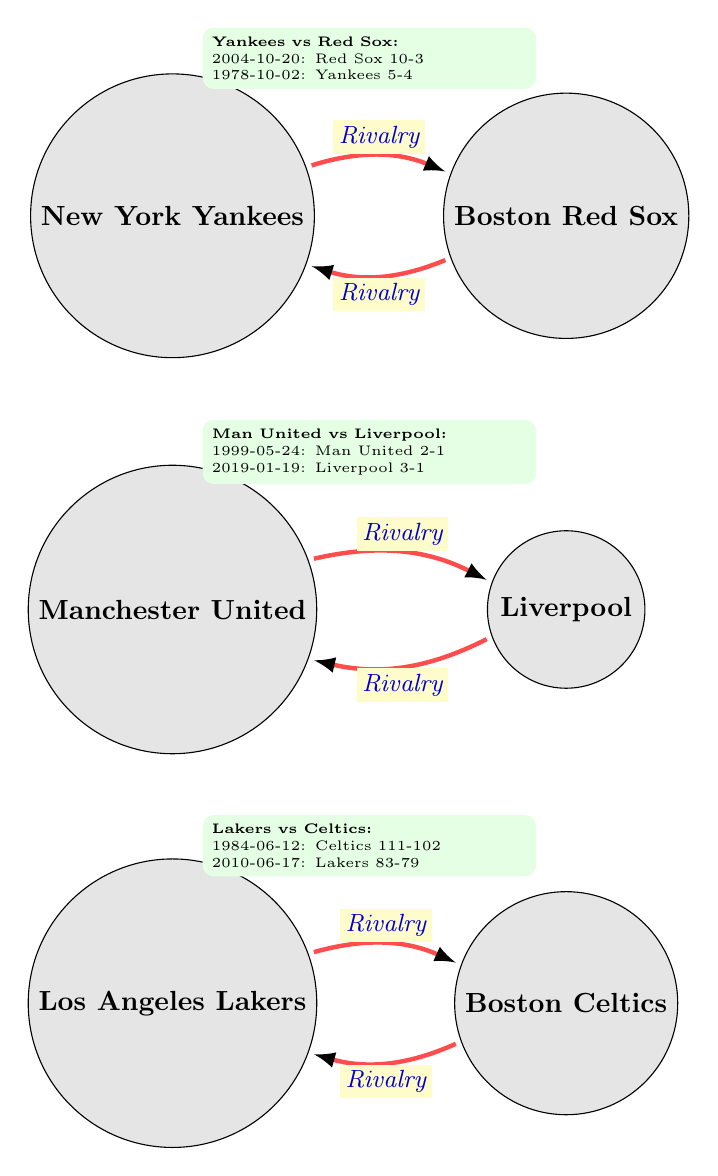What two teams are connected by the rivalry link in the top section of the diagram? The top section features a rivalry link between the New York Yankees and the Boston Red Sox. You can see that these two teams have a labeled edge connecting them, indicating their rivalry.
Answer: New York Yankees, Boston Red Sox How many nodes are in the diagram? The diagram has a total of six nodes, each representing a sports team. Counting the nodes labeled as teams, we find: Yankees, Red Sox, Manchester United, Liverpool, Lakers, and Celtics, making a total of six.
Answer: 6 What was the outcome of the historic match on 2004-10-20 between the Yankees and the Red Sox? The historical match on 2004-10-20 indicates that the Boston Red Sox won against the New York Yankees. This outcome is highlighted in the rivalry information between these two teams.
Answer: Red Sox Win Which team lost on June 12, 1984, in the historic match between the Lakers and Celtics? In the historical match on June 12, 1984, the Los Angeles Lakers lost to the Boston Celtics. The match details show the Celtics winning by a score of 111-102.
Answer: Lakers What is the significance of the match where Manchester United won against Liverpool on May 24, 1999? The significance of the match where Manchester United won against Liverpool on May 24, 1999, is noted as it was part of the FA Cup and pivotal in United's Treble-winning season. This context is provided in the historical match details.
Answer: FA Cup, United's Treble-winning season Which rivalry link is positioned at the bottom of the diagram? The rivalry link positioned at the bottom of the diagram connects the Los Angeles Lakers and the Boston Celtics. This edge is located lower than the other rivalries listed in the chart.
Answer: Lakers, Celtics What score did the Celtics win by in the historic match against the Lakers on June 17, 2010? The historical match on June 17, 2010, shows that the Boston Celtics won against the Los Angeles Lakers with a score of 83-79. This detail is clearly found in the rivalry information.
Answer: 83-79 